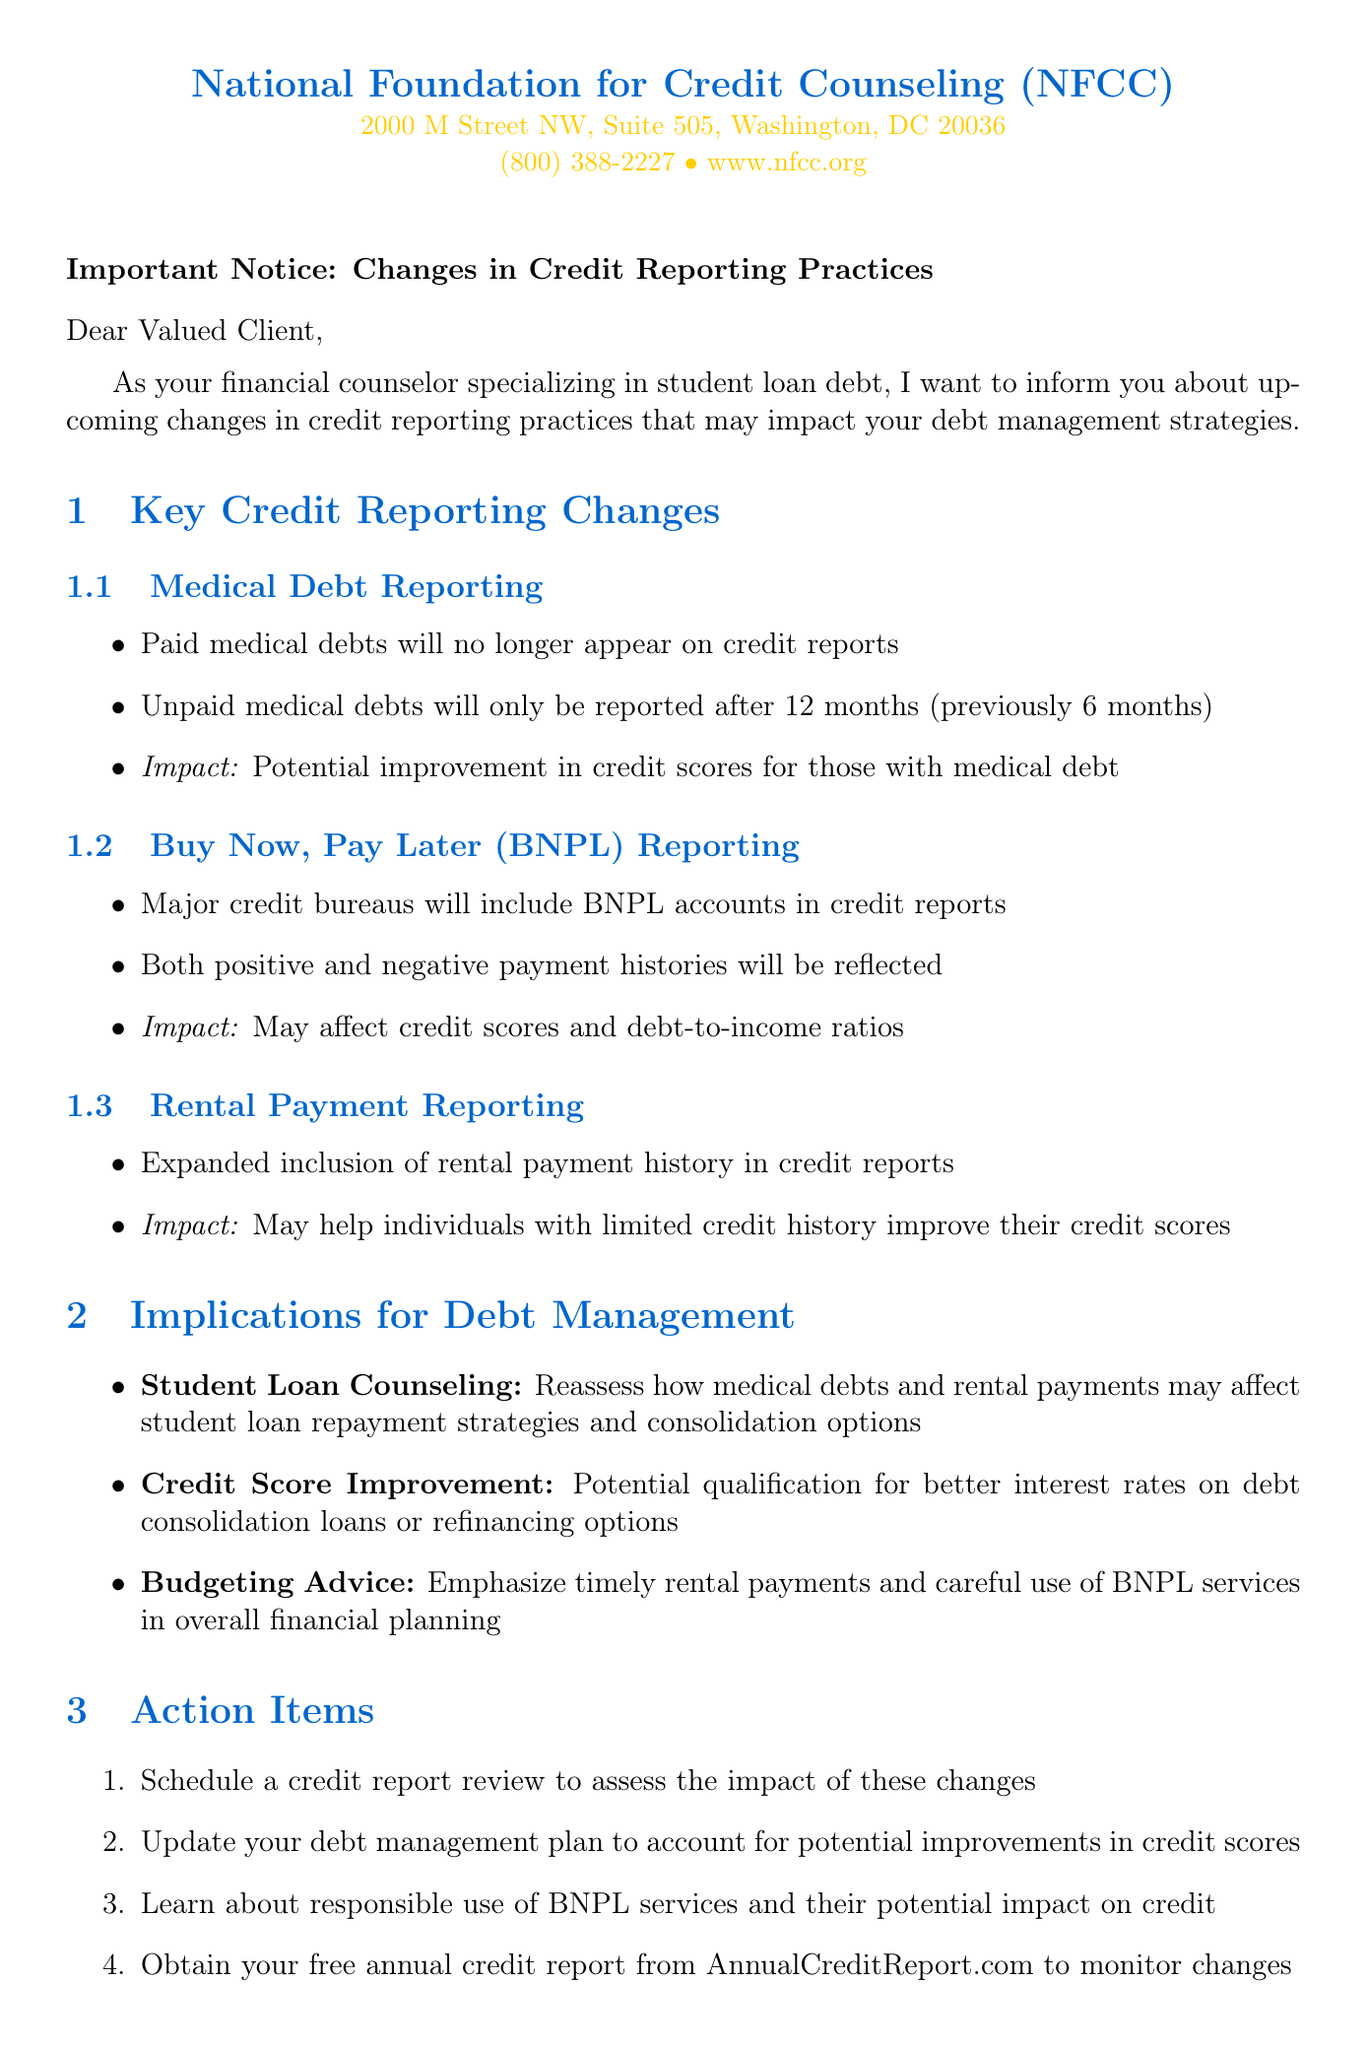What is the name of the agency mentioned in the notice? The agency mentioned in the notice is the National Foundation for Credit Counseling.
Answer: National Foundation for Credit Counseling What is the address of the NFCC? The document states the address of the NFCC as 2000 M Street NW, Suite 505, Washington, DC 20036.
Answer: 2000 M Street NW, Suite 505, Washington, DC 20036 What change is related to medical debt reporting? The change regarding medical debt reporting is that unpaid medical debts will only be reported after 12 months instead of 6 months.
Answer: Unpaid medical debts will only be reported after 12 months What is one implication of credit score improvement mentioned in the document? One implication is that clients may qualify for better interest rates on debt consolidation loans or refinancing options.
Answer: Better interest rates on debt consolidation loans How many action items are listed in the document? The document lists four action items for clients regarding the credit reporting changes.
Answer: Four What resource provides information on credit reporting practices? The Consumer Financial Protection Bureau offers up-to-date information on credit reporting practices and consumer rights.
Answer: Consumer Financial Protection Bureau What aspect of debt management does the letter emphasize in relation to rental payments? The letter emphasizes the importance of timely rental payments in overall financial planning and debt management.
Answer: Timely rental payments What phone number can clients call for assistance? The document lists the phone number for the NFCC as (800) 388-2227.
Answer: (800) 388-2227 